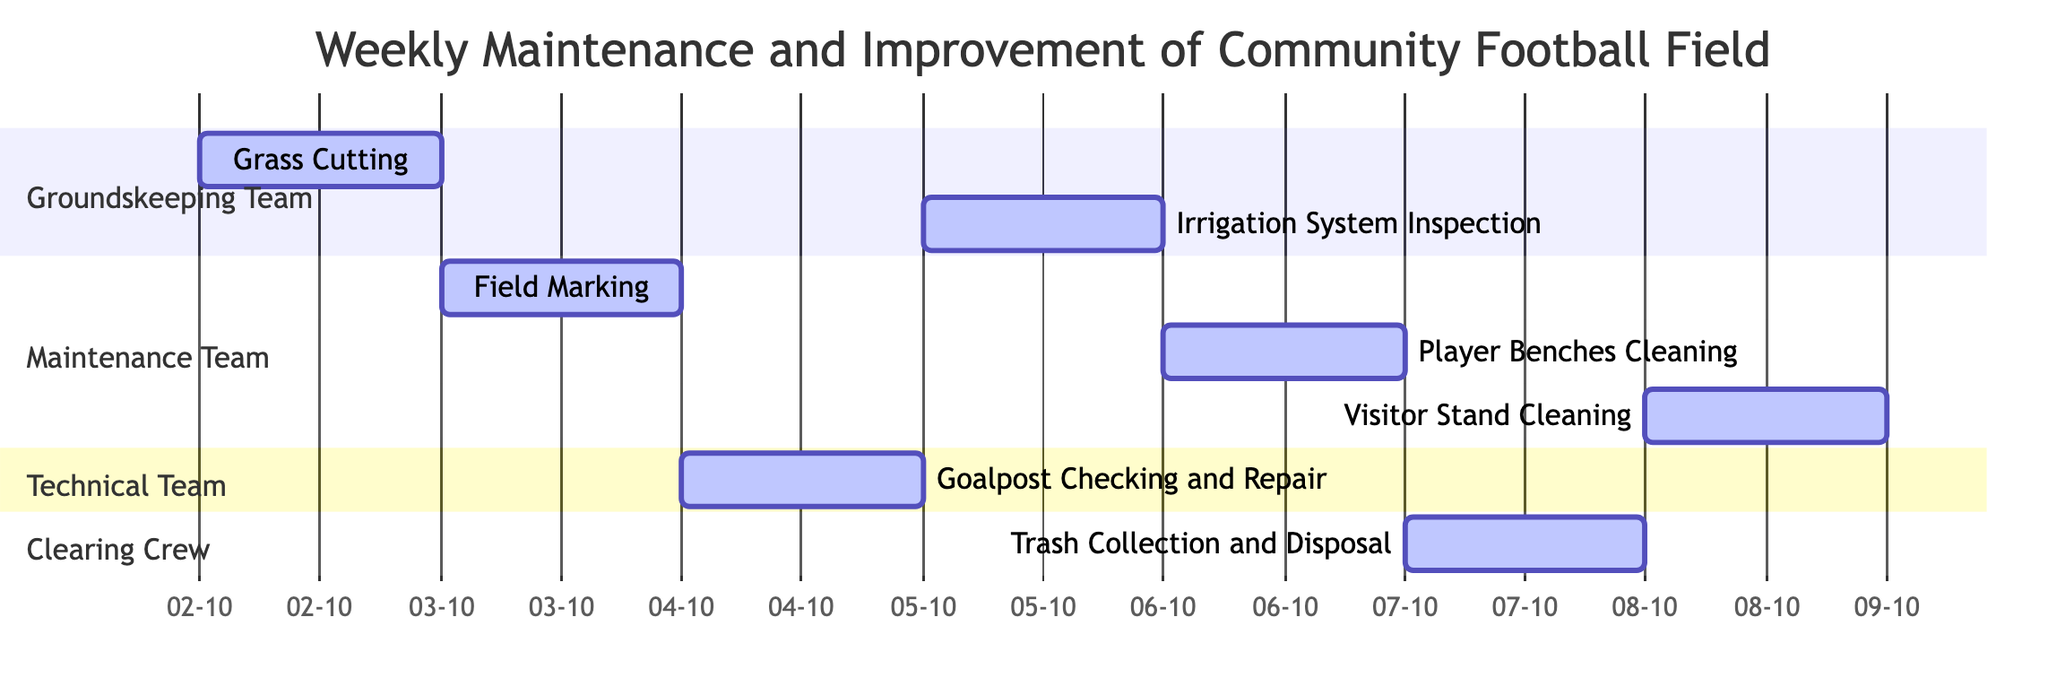What is the first task scheduled? The first task in the Gantt chart is "Grass Cutting," which has a start date of October 2, 2023.
Answer: Grass Cutting How many tasks are assigned to the Maintenance Team? The Gantt chart lists three tasks assigned to the Maintenance Team: "Field Marking," "Player Benches Cleaning," and "Visitor Stand Cleaning."
Answer: 3 What is the end date of the "Irrigation System Inspection"? The end date for the "Irrigation System Inspection" task, which is assigned to the Groundskeeping Team, is October 5, 2023.
Answer: 2023-10-05 Which team is responsible for cleaning the Visitor Stand? The task "Visitor Stand Cleaning" falls under the Maintenance Team, indicating they are responsible for this task.
Answer: Maintenance Team What task is scheduled directly after "Goalpost Checking and Repair"? Following "Goalpost Checking and Repair," which occurs on October 4, 2023, the next task is "Irrigation System Inspection" on October 5, 2023.
Answer: Irrigation System Inspection How many days are allocated for Trash Collection and Disposal? The "Trash Collection and Disposal" task is allocated for one day as indicated in the Gantt chart.
Answer: 1 day Which task occurs on October 6, 2023? The task scheduled for October 6, 2023, is "Player Benches Cleaning," as shown in the Gantt chart.
Answer: Player Benches Cleaning What is the total number of tasks listed in the diagram? The Gantt chart displays a total of seven tasks that are scheduled for the weekly maintenance and improvement work.
Answer: 7 What does the bar represent in a Gantt chart? In a Gantt chart, the bar represents the duration of the task, showing when it starts and ends.
Answer: Duration of tasks 